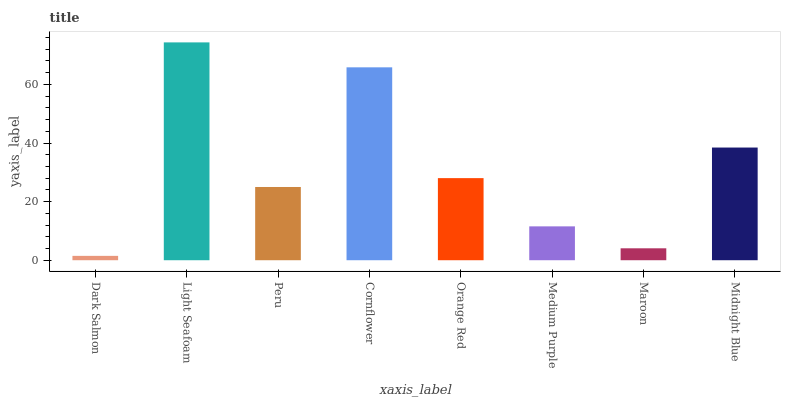Is Dark Salmon the minimum?
Answer yes or no. Yes. Is Light Seafoam the maximum?
Answer yes or no. Yes. Is Peru the minimum?
Answer yes or no. No. Is Peru the maximum?
Answer yes or no. No. Is Light Seafoam greater than Peru?
Answer yes or no. Yes. Is Peru less than Light Seafoam?
Answer yes or no. Yes. Is Peru greater than Light Seafoam?
Answer yes or no. No. Is Light Seafoam less than Peru?
Answer yes or no. No. Is Orange Red the high median?
Answer yes or no. Yes. Is Peru the low median?
Answer yes or no. Yes. Is Light Seafoam the high median?
Answer yes or no. No. Is Midnight Blue the low median?
Answer yes or no. No. 